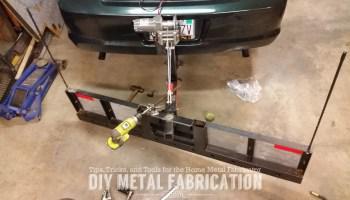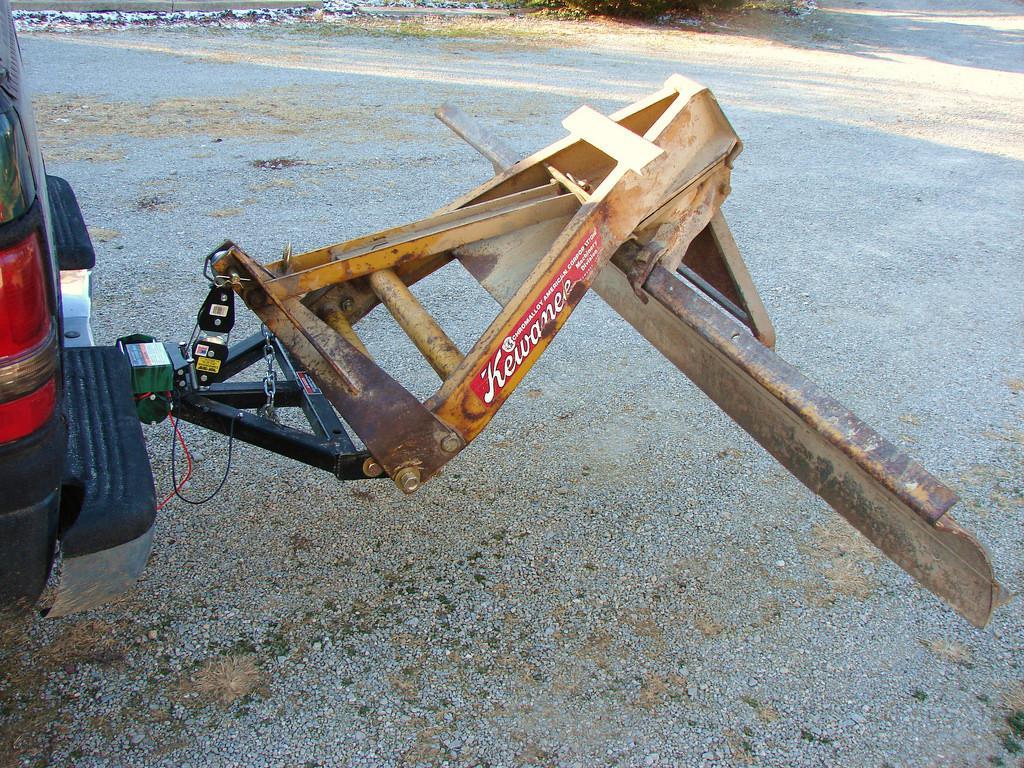The first image is the image on the left, the second image is the image on the right. Considering the images on both sides, is "An image shows a dark pickup truck pulling a plow on a snowy street." valid? Answer yes or no. No. 